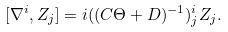Convert formula to latex. <formula><loc_0><loc_0><loc_500><loc_500>[ \nabla ^ { i } , Z _ { j } ] = i ( ( C \Theta + D ) ^ { - 1 } ) _ { j } ^ { i } Z _ { j } .</formula> 